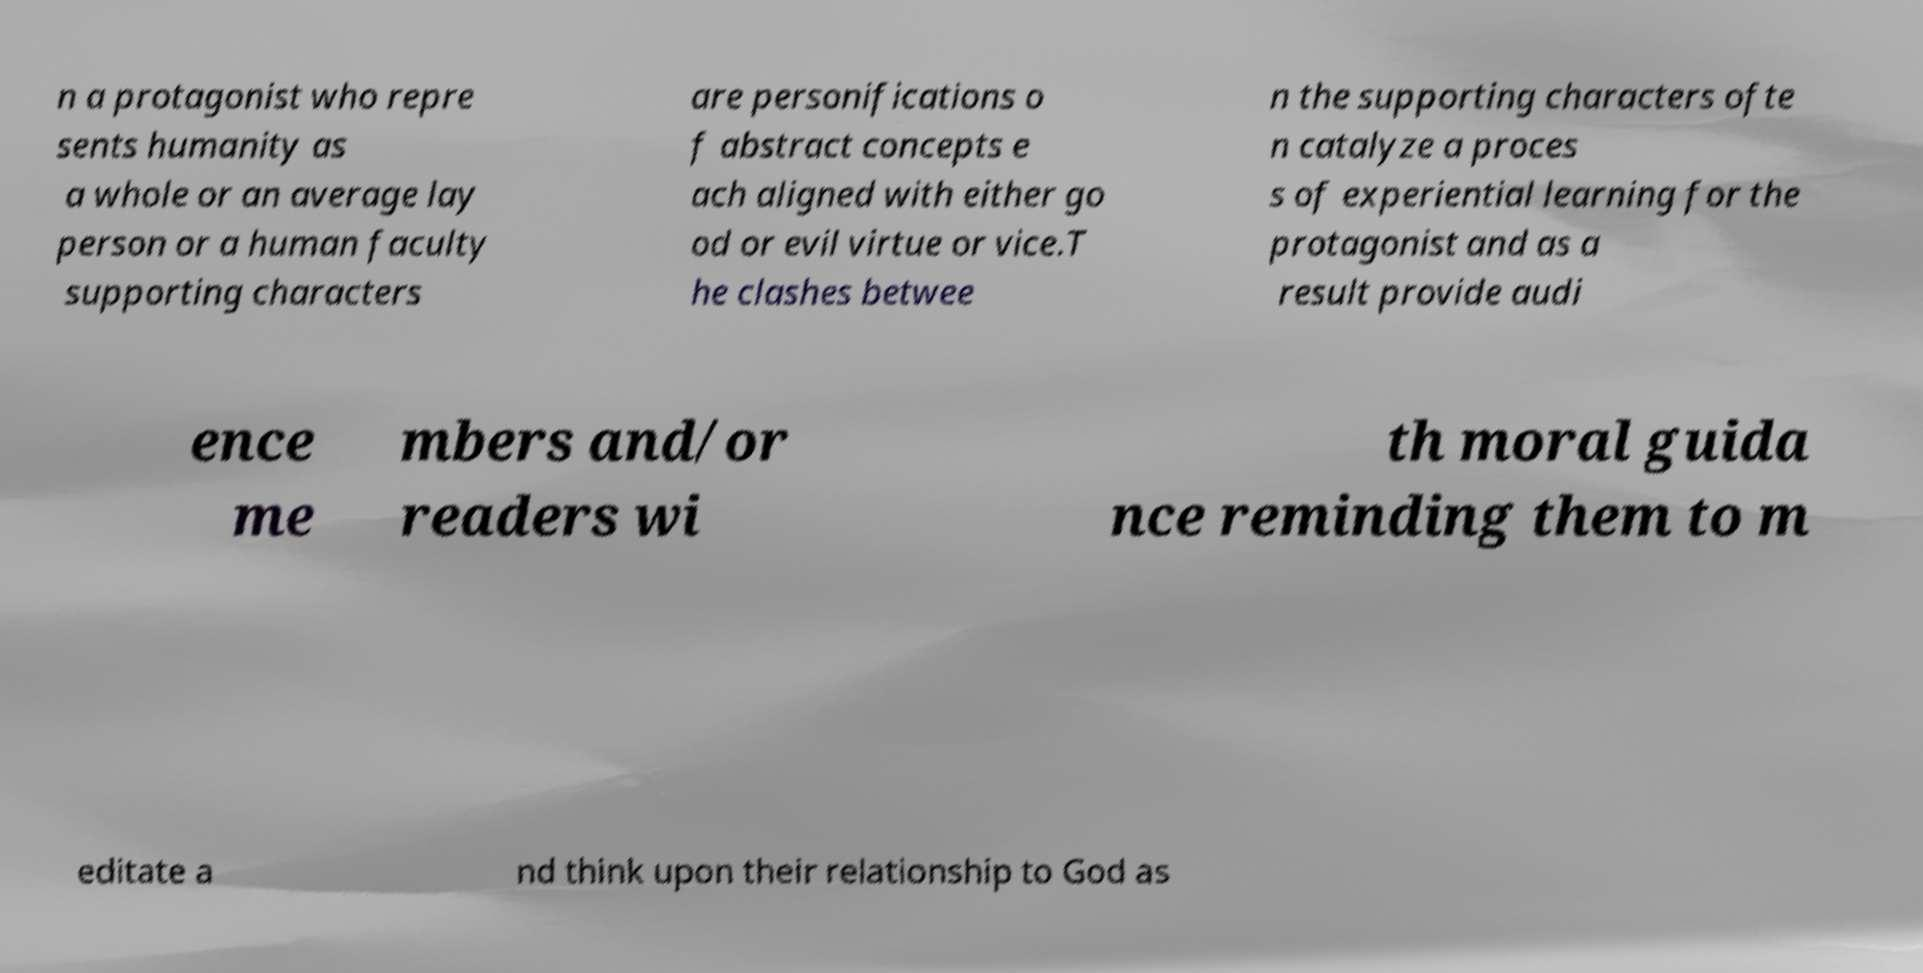Please read and relay the text visible in this image. What does it say? n a protagonist who repre sents humanity as a whole or an average lay person or a human faculty supporting characters are personifications o f abstract concepts e ach aligned with either go od or evil virtue or vice.T he clashes betwee n the supporting characters ofte n catalyze a proces s of experiential learning for the protagonist and as a result provide audi ence me mbers and/or readers wi th moral guida nce reminding them to m editate a nd think upon their relationship to God as 